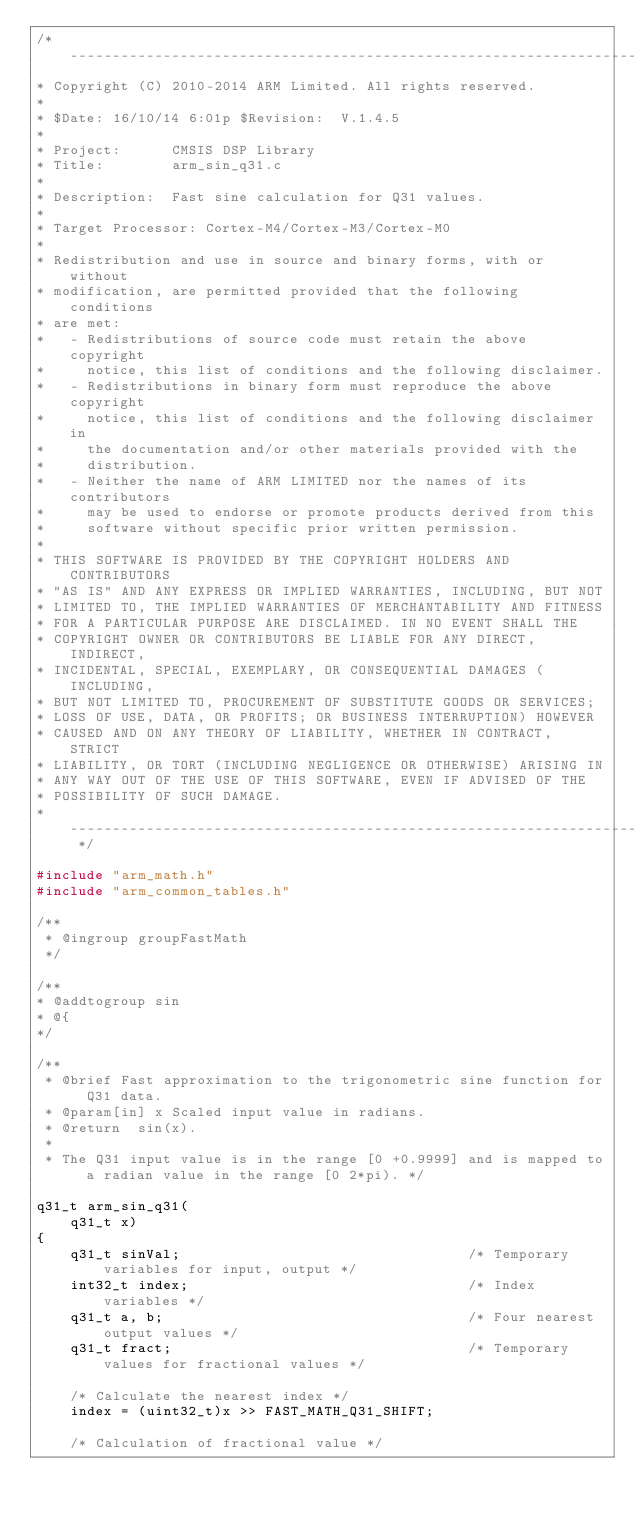Convert code to text. <code><loc_0><loc_0><loc_500><loc_500><_C_>/* ----------------------------------------------------------------------
* Copyright (C) 2010-2014 ARM Limited. All rights reserved.
*
* $Date: 16/10/14 6:01p $Revision:  V.1.4.5
*
* Project:      CMSIS DSP Library
* Title:        arm_sin_q31.c
*
* Description:  Fast sine calculation for Q31 values.
*
* Target Processor: Cortex-M4/Cortex-M3/Cortex-M0
*
* Redistribution and use in source and binary forms, with or without
* modification, are permitted provided that the following conditions
* are met:
*   - Redistributions of source code must retain the above copyright
*     notice, this list of conditions and the following disclaimer.
*   - Redistributions in binary form must reproduce the above copyright
*     notice, this list of conditions and the following disclaimer in
*     the documentation and/or other materials provided with the
*     distribution.
*   - Neither the name of ARM LIMITED nor the names of its contributors
*     may be used to endorse or promote products derived from this
*     software without specific prior written permission.
*
* THIS SOFTWARE IS PROVIDED BY THE COPYRIGHT HOLDERS AND CONTRIBUTORS
* "AS IS" AND ANY EXPRESS OR IMPLIED WARRANTIES, INCLUDING, BUT NOT
* LIMITED TO, THE IMPLIED WARRANTIES OF MERCHANTABILITY AND FITNESS
* FOR A PARTICULAR PURPOSE ARE DISCLAIMED. IN NO EVENT SHALL THE
* COPYRIGHT OWNER OR CONTRIBUTORS BE LIABLE FOR ANY DIRECT, INDIRECT,
* INCIDENTAL, SPECIAL, EXEMPLARY, OR CONSEQUENTIAL DAMAGES (INCLUDING,
* BUT NOT LIMITED TO, PROCUREMENT OF SUBSTITUTE GOODS OR SERVICES;
* LOSS OF USE, DATA, OR PROFITS; OR BUSINESS INTERRUPTION) HOWEVER
* CAUSED AND ON ANY THEORY OF LIABILITY, WHETHER IN CONTRACT, STRICT
* LIABILITY, OR TORT (INCLUDING NEGLIGENCE OR OTHERWISE) ARISING IN
* ANY WAY OUT OF THE USE OF THIS SOFTWARE, EVEN IF ADVISED OF THE
* POSSIBILITY OF SUCH DAMAGE.
* -------------------------------------------------------------------- */

#include "arm_math.h"
#include "arm_common_tables.h"

/**
 * @ingroup groupFastMath
 */

/**
* @addtogroup sin
* @{
*/

/**
 * @brief Fast approximation to the trigonometric sine function for Q31 data.
 * @param[in] x Scaled input value in radians.
 * @return  sin(x).
 *
 * The Q31 input value is in the range [0 +0.9999] and is mapped to a radian value in the range [0 2*pi). */

q31_t arm_sin_q31(
    q31_t x)
{
    q31_t sinVal;                                  /* Temporary variables for input, output */
    int32_t index;                                 /* Index variables */
    q31_t a, b;                                    /* Four nearest output values */
    q31_t fract;                                   /* Temporary values for fractional values */

    /* Calculate the nearest index */
    index = (uint32_t)x >> FAST_MATH_Q31_SHIFT;

    /* Calculation of fractional value */</code> 